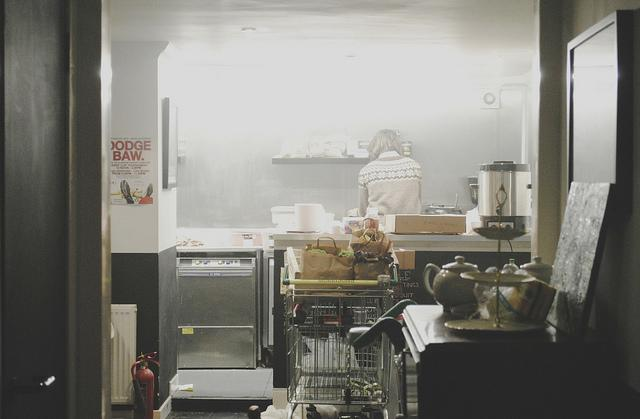What is the woman doing?

Choices:
A) eating
B) talking
C) sleeping
D) working working 